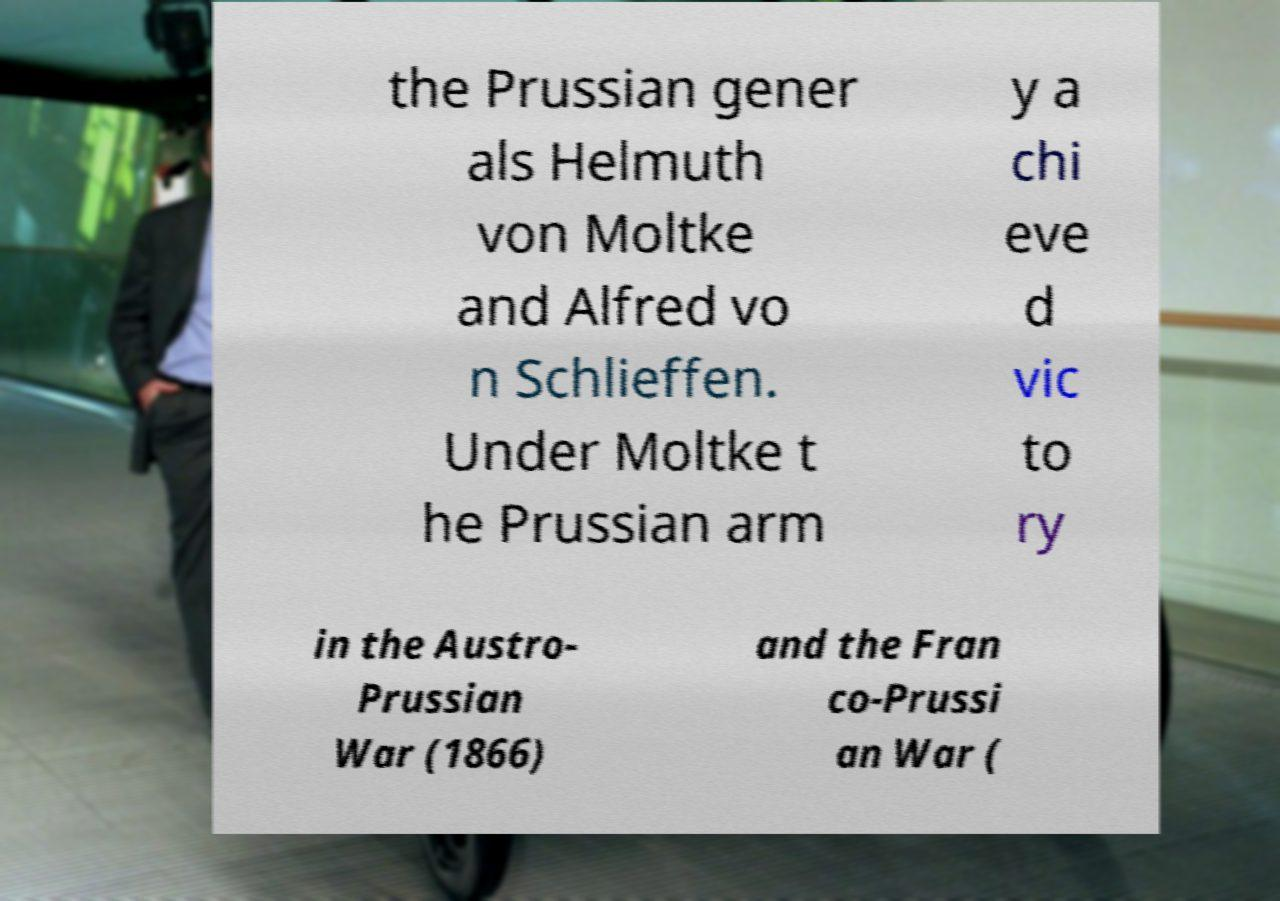Please read and relay the text visible in this image. What does it say? the Prussian gener als Helmuth von Moltke and Alfred vo n Schlieffen. Under Moltke t he Prussian arm y a chi eve d vic to ry in the Austro- Prussian War (1866) and the Fran co-Prussi an War ( 